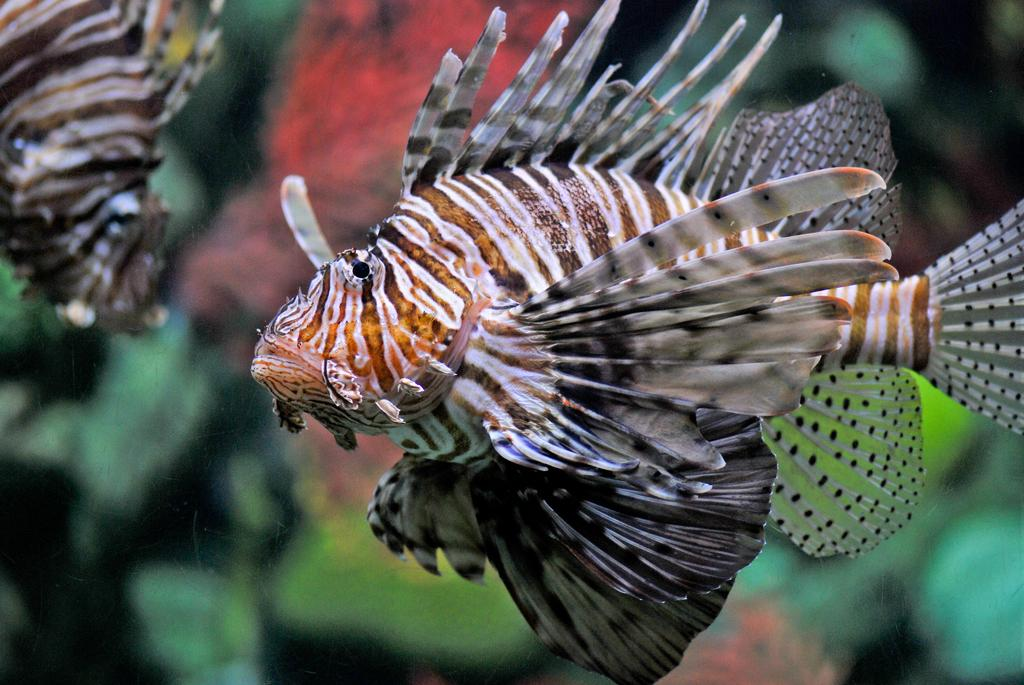What type of animals can be seen in the image? There are fishes in the image. What color are the fishes in the image? The fishes are in black and white color. What colors are present in the background of the image? The background of the image is in red and green color. How would you describe the appearance of the background? The background is blurred. What type of suit is the jelly wearing in the image? There is no jelly or suit present in the image; it features black and white fishes with a red and green blurred background. 